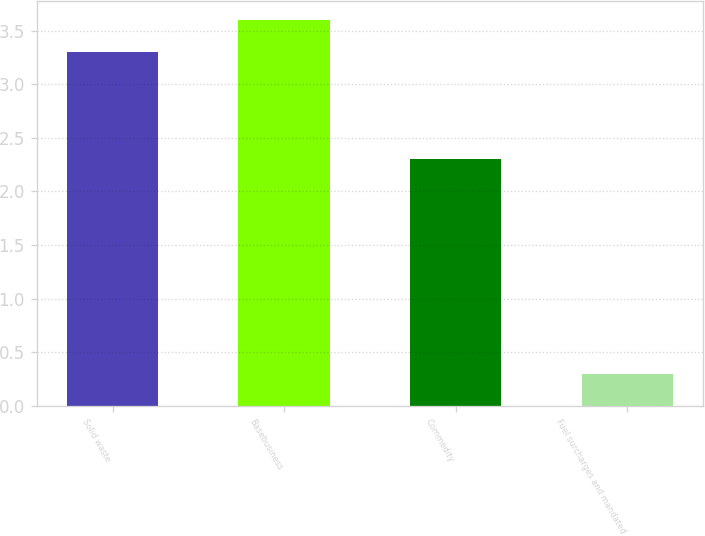Convert chart. <chart><loc_0><loc_0><loc_500><loc_500><bar_chart><fcel>Solid waste<fcel>Basebusiness<fcel>Commodity<fcel>Fuel surcharges and mandated<nl><fcel>3.3<fcel>3.6<fcel>2.3<fcel>0.3<nl></chart> 